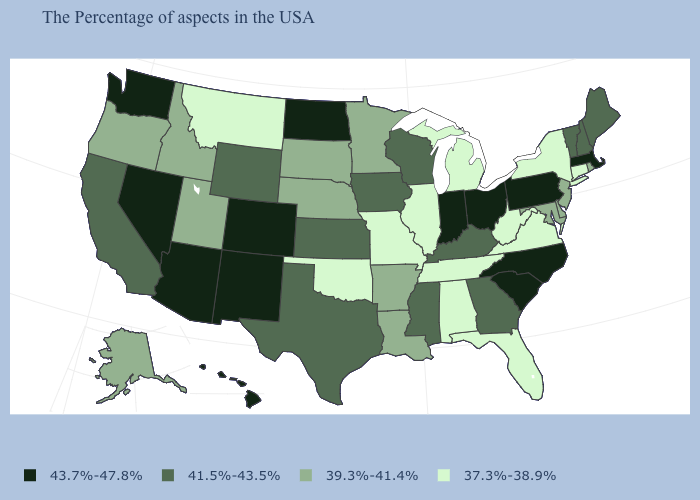Among the states that border Nevada , which have the lowest value?
Concise answer only. Utah, Idaho, Oregon. What is the lowest value in the USA?
Concise answer only. 37.3%-38.9%. Among the states that border Montana , which have the highest value?
Short answer required. North Dakota. Does the map have missing data?
Write a very short answer. No. What is the value of North Carolina?
Be succinct. 43.7%-47.8%. Among the states that border New York , which have the lowest value?
Be succinct. Connecticut. Among the states that border Indiana , which have the highest value?
Answer briefly. Ohio. Name the states that have a value in the range 39.3%-41.4%?
Keep it brief. Rhode Island, New Jersey, Delaware, Maryland, Louisiana, Arkansas, Minnesota, Nebraska, South Dakota, Utah, Idaho, Oregon, Alaska. Among the states that border Delaware , which have the highest value?
Be succinct. Pennsylvania. Name the states that have a value in the range 37.3%-38.9%?
Short answer required. Connecticut, New York, Virginia, West Virginia, Florida, Michigan, Alabama, Tennessee, Illinois, Missouri, Oklahoma, Montana. Name the states that have a value in the range 37.3%-38.9%?
Give a very brief answer. Connecticut, New York, Virginia, West Virginia, Florida, Michigan, Alabama, Tennessee, Illinois, Missouri, Oklahoma, Montana. What is the value of Massachusetts?
Keep it brief. 43.7%-47.8%. Does Utah have the lowest value in the USA?
Short answer required. No. Does Michigan have the lowest value in the MidWest?
Short answer required. Yes. 